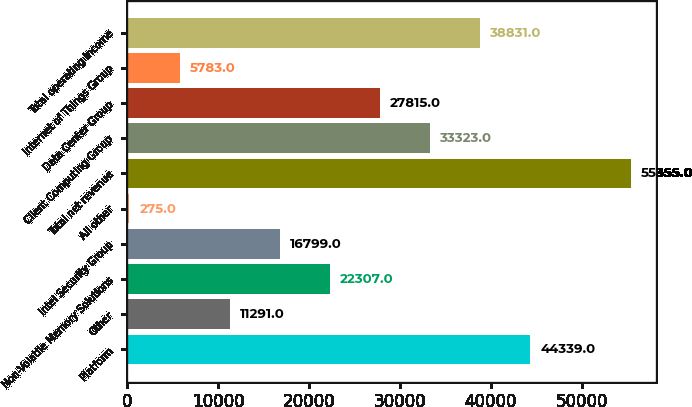Convert chart to OTSL. <chart><loc_0><loc_0><loc_500><loc_500><bar_chart><fcel>Platform<fcel>Other<fcel>Non-Volatile Memory Solutions<fcel>Intel Security Group<fcel>All other<fcel>Total net revenue<fcel>Client Computing Group<fcel>Data Center Group<fcel>Internet of Things Group<fcel>Total operating income<nl><fcel>44339<fcel>11291<fcel>22307<fcel>16799<fcel>275<fcel>55355<fcel>33323<fcel>27815<fcel>5783<fcel>38831<nl></chart> 